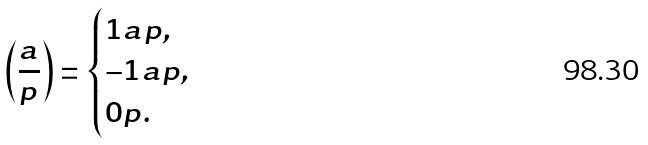<formula> <loc_0><loc_0><loc_500><loc_500>\left ( \frac { a } { p } \right ) = \begin{cases} 1 a p , \\ - 1 a p , \\ 0 p . \ \end{cases}</formula> 